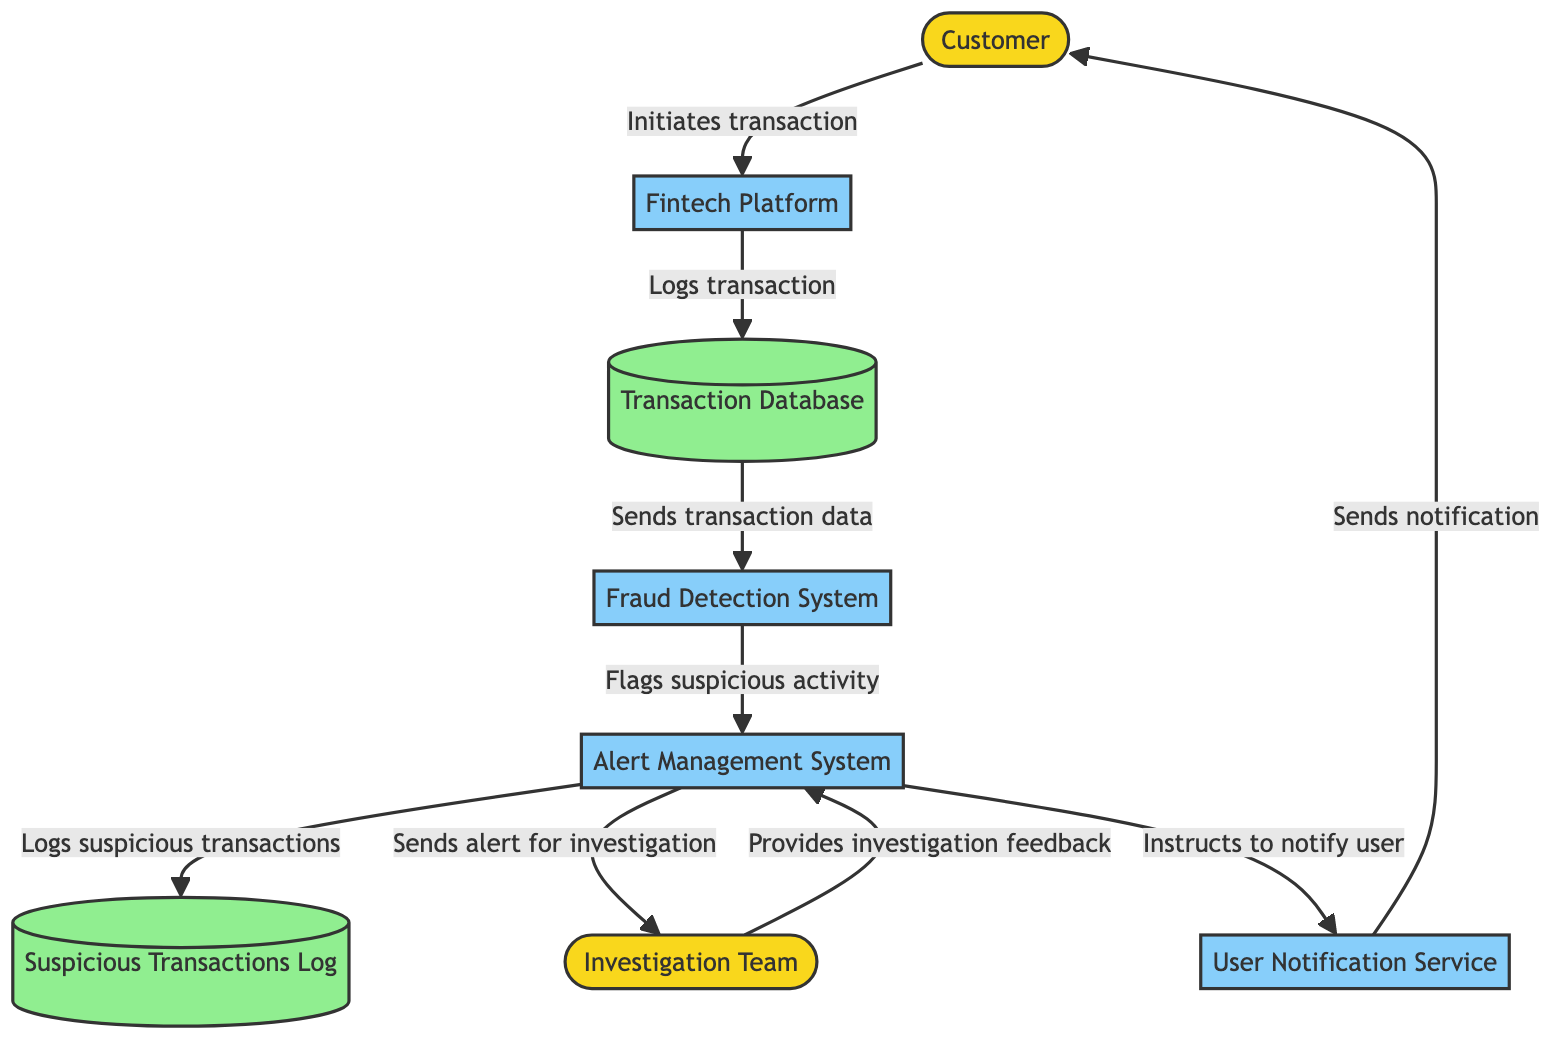What is the total number of entities in the diagram? The diagram features three entities: Customer, Investigation Team, and Fintech Platform, which are categorized as external entities.
Answer: 3 Which process handles real-time transaction analysis? The diagram indicates that the Fraud Detection System is responsible for analyzing transactions in real-time to detect any suspicious activities.
Answer: Fraud Detection System What data store logs suspicious transactions? According to the diagram, the Suspicious Transactions Log is the data store that records details of transactions flagged as suspicious.
Answer: Suspicious Transactions Log How does the investigation team receive alerts? The diagram illustrates that the Alert Management System sends alerts for investigation directly to the Investigation Team, which indicates the flow of information between these two components.
Answer: Sends alert for investigation What action does the User Notification Service perform? The diagram shows that the User Notification Service sends notifications to the Customer, which means its role is to inform customers about any matters related to suspicious activities.
Answer: Sends notification How many data flows are present in the diagram? By examining the diagram’s connections, one can count a total of nine distinct data flows that illustrate the interactions among different components of the fraud detection mechanism.
Answer: 9 Which process logs the transaction details in the Transaction Database? The Fintech Platform is responsible for logging transaction details in the Transaction Database as represented in the diagram, indicating its role in managing transaction records.
Answer: Logs transaction What does the Alert Management System do after it receives flags from the Fraud Detection System? The diagram demonstrates that after receiving flags for suspicious activity from the Fraud Detection System, the Alert Management System logs these transactions and sends alerts to the Investigation Team.
Answer: Logs suspicious transactions and sends alert for investigation Which entity initiates the transaction process? From the diagram, it is clear that the Customer is the entity that initiates the transaction process by interacting with the Fintech Platform.
Answer: Customer 